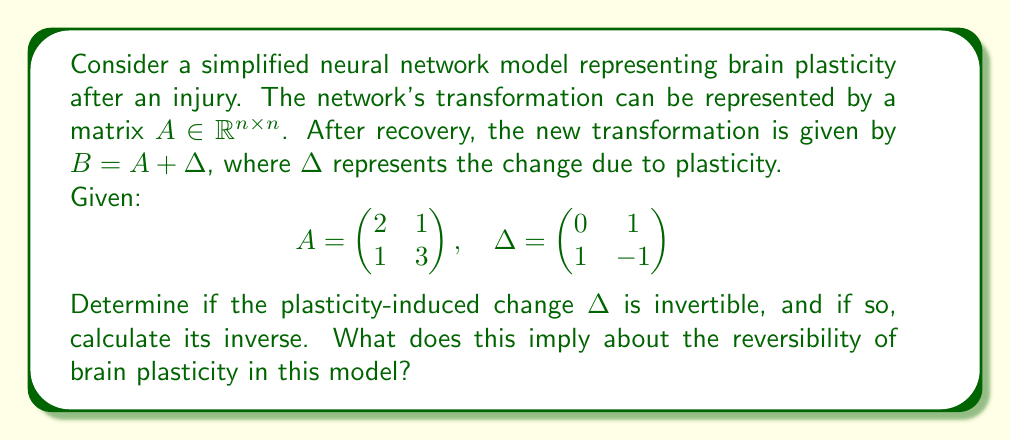Can you solve this math problem? To determine if $\Delta$ is invertible and calculate its inverse, we'll follow these steps:

1) First, we need to check if $\Delta$ is invertible. A matrix is invertible if and only if its determinant is non-zero.

2) Calculate the determinant of $\Delta$:
   $$\det(\Delta) = (0 \cdot -1) - (1 \cdot 1) = 0 - 1 = -1$$

3) Since $\det(\Delta) \neq 0$, $\Delta$ is invertible.

4) To find the inverse of $\Delta$, we'll use the formula for 2x2 matrices:
   For a matrix $\begin{pmatrix} a & b \\ c & d \end{pmatrix}$, its inverse is:
   $$\frac{1}{ad-bc} \begin{pmatrix} d & -b \\ -c & a \end{pmatrix}$$

5) Applying this to $\Delta$:
   $$\Delta^{-1} = \frac{1}{(0 \cdot -1) - (1 \cdot 1)} \begin{pmatrix} -1 & -1 \\ -1 & 0 \end{pmatrix}$$

6) Simplifying:
   $$\Delta^{-1} = -1 \begin{pmatrix} -1 & -1 \\ -1 & 0 \end{pmatrix} = \begin{pmatrix} 1 & 1 \\ 1 & 0 \end{pmatrix}$$

7) Interpretation: The invertibility of $\Delta$ implies that the plasticity-induced change is theoretically reversible in this model. This means that if we apply $\Delta^{-1}$ to the transformed network $B$, we could potentially recover the original network $A$:

   $$A = B - \Delta = (A + \Delta) - \Delta = A + (\Delta - \Delta) = A$$

   However, it's important to note that this mathematical reversibility doesn't necessarily translate to biological reversibility in real brain plasticity.
Answer: $\Delta^{-1} = \begin{pmatrix} 1 & 1 \\ 1 & 0 \end{pmatrix}$; plasticity change is theoretically reversible. 